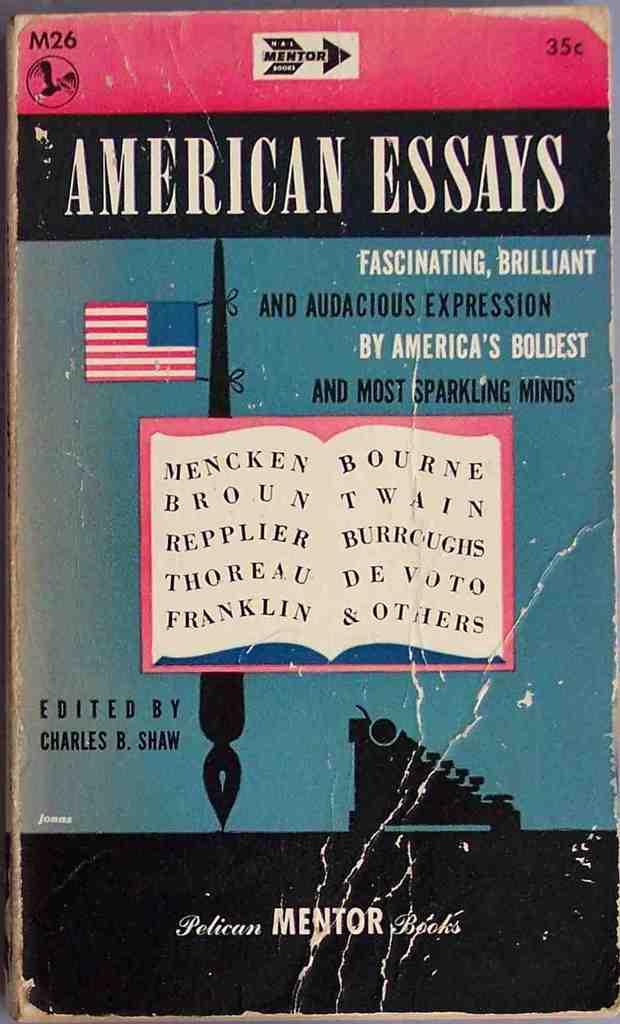<image>
Render a clear and concise summary of the photo. a book that has the title 'american essays' at the top of it 